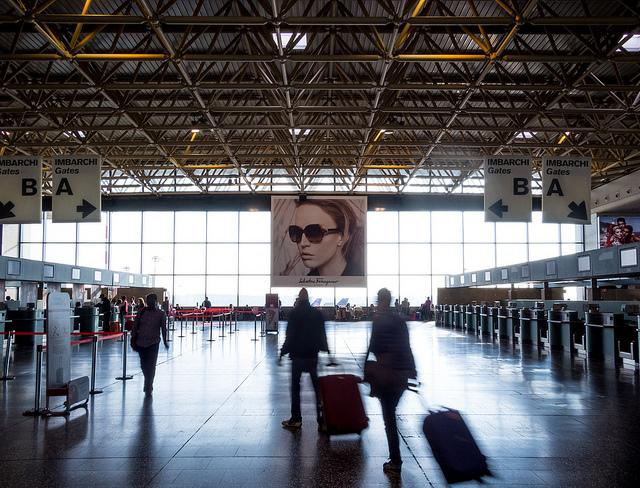This Imbarchi gates are updated as automatic open by using what? card 